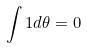Convert formula to latex. <formula><loc_0><loc_0><loc_500><loc_500>\int 1 d \theta = 0</formula> 